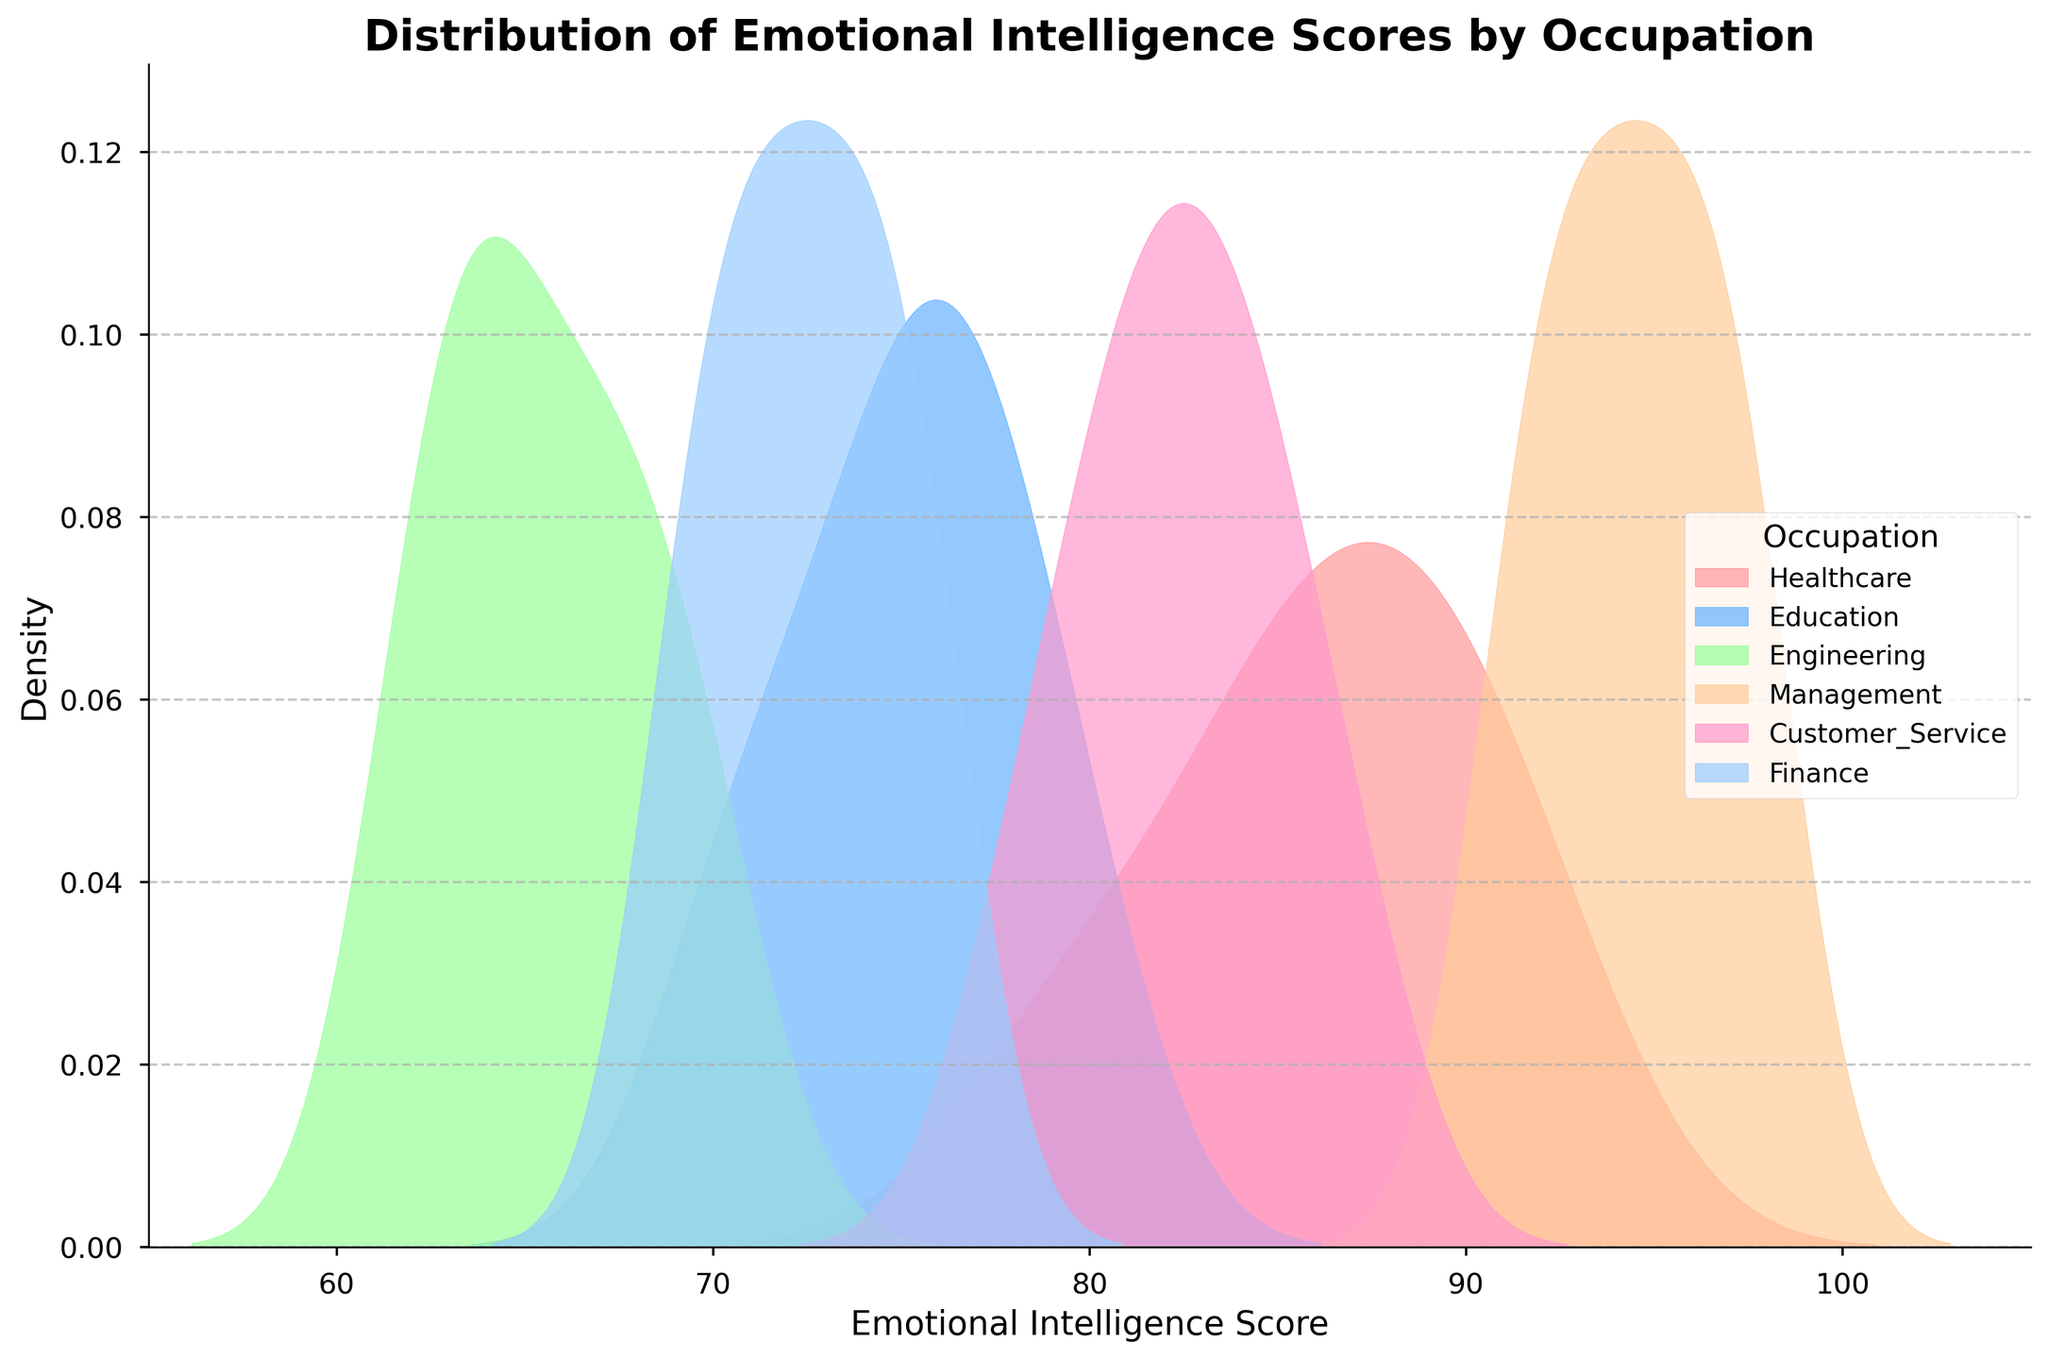What does the title of the plot say? The title of the plot is displayed at the top of the figure and provides a summary of what the plot is depicting.
Answer: Distribution of Emotional Intelligence Scores by Occupation Which occupational category has the peak density in the highest range of Emotional Intelligence Scores? Observe the plot to see which category's curve peaks at the highest score values on the x-axis.
Answer: Management What can you infer about the density distribution of Engineering compared to Healthcare? Compare the density curve of Engineering with that of Healthcare across the x-axis to identify shifts, spread, and peaks.
Answer: Engineering shows a lower and more spread out density, with peaks at lower scores compared to Healthcare Which occupational category appears to have the lowest range of Emotional Intelligence Scores? Look for the category whose density curve is shifted most to the lower end of the x-axis.
Answer: Engineering Between Education and Customer Service, which category has a wider spread of Emotional Intelligence Scores? Compare the spread of the density curves for Education and Customer Service. A wider spread indicates a broader range of scores.
Answer: Education What is the approximate range of Emotional Intelligence Scores for the Finance category? Determine the lower and upper limits of the score range where the Finance density curve is present on the x-axis.
Answer: Approximately 65 to 80 What color is used to represent the Healthcare category? Identify the color of the density curve corresponding to the Healthcare category in the legend.
Answer: Light red/pink How does the Emotional Intelligence Score distribution for Management compare to Customer Service? Compare both density curves aspects such as peak, spread, and position on the x-axis.
Answer: Management scores are higher and more concentrated; Customer Service has a more even spread What observations can you make about the overlap between any two categories' distributions? Look at the areas where the density curves of different categories intersect to determine overlap regions and extent.
Answer: For example, Customer Service and Healthcare overlap significantly, indicating similar score distributions in some range What can you say about the density peak of the Finance category? Examine where the highest density point of the Finance category's curve is located on the x-axis.
Answer: Around the scores 72-74 Which occupational category has the sharpest peak in Emotional Intelligence Scores distribution? Look for the category with the steepest and most prominent peak in its density curve.
Answer: Management 